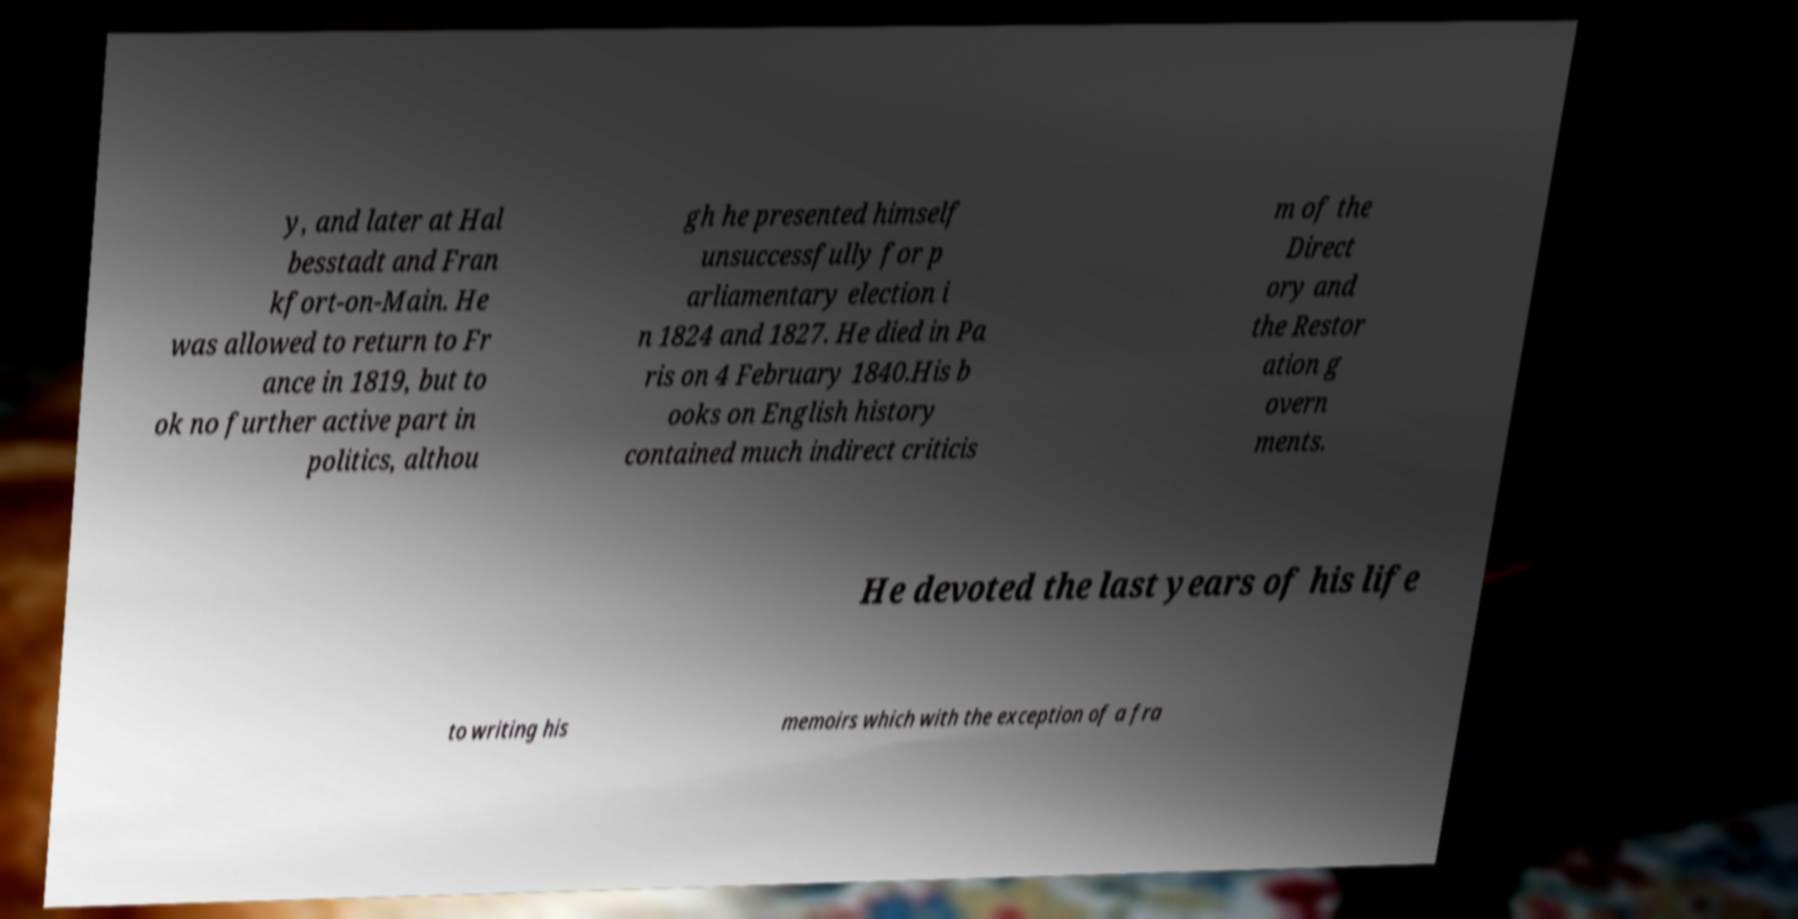For documentation purposes, I need the text within this image transcribed. Could you provide that? y, and later at Hal besstadt and Fran kfort-on-Main. He was allowed to return to Fr ance in 1819, but to ok no further active part in politics, althou gh he presented himself unsuccessfully for p arliamentary election i n 1824 and 1827. He died in Pa ris on 4 February 1840.His b ooks on English history contained much indirect criticis m of the Direct ory and the Restor ation g overn ments. He devoted the last years of his life to writing his memoirs which with the exception of a fra 